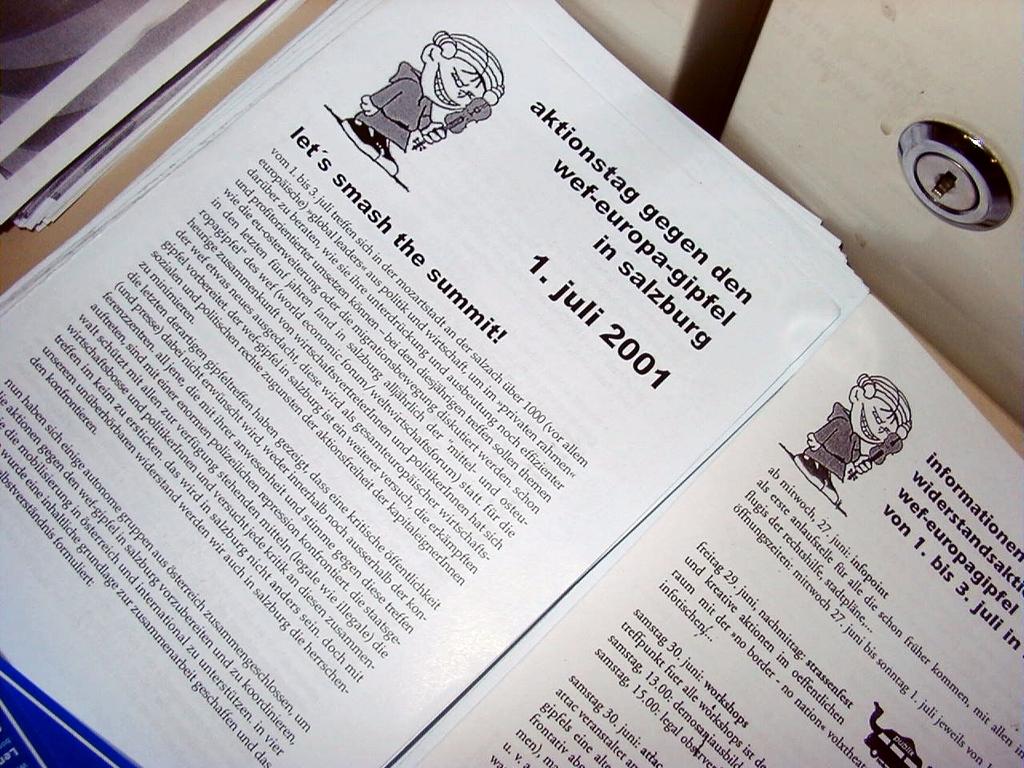What does the book say to do to the summit?
Provide a short and direct response. Smash. What is the date up top?
Ensure brevity in your answer.  Juli 2001. 